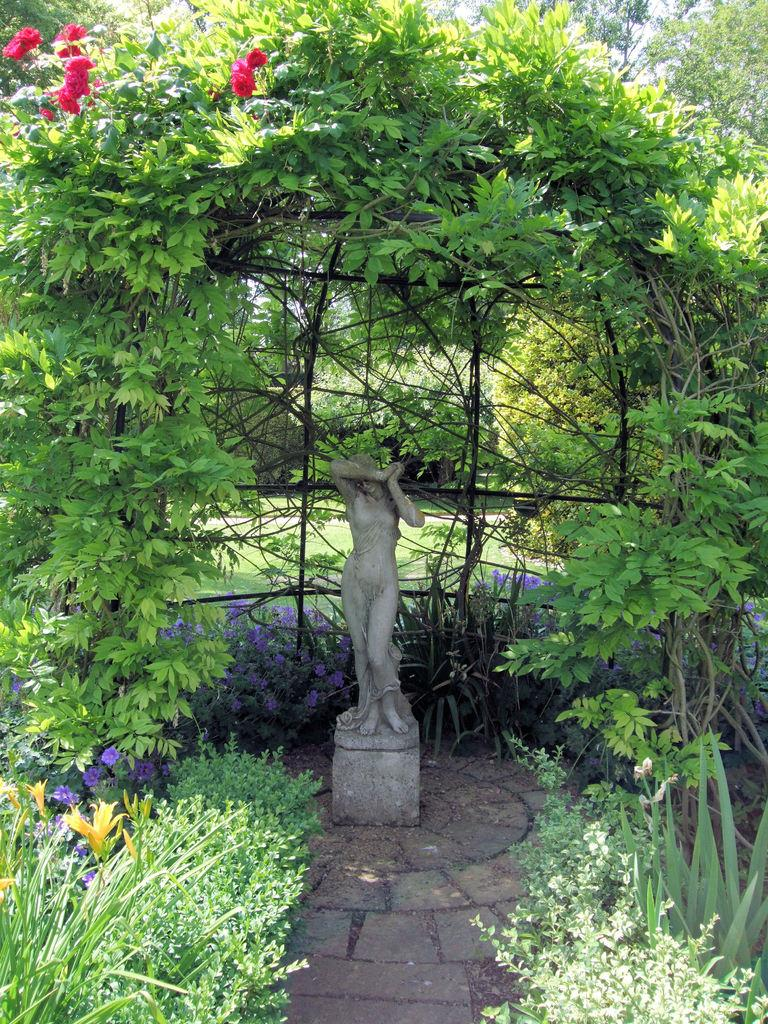What is the main subject of the image? There is a sculpture in the image. What other elements can be seen in the image besides the sculpture? There are plants, trees, and flowers in the image. What type of furniture is depicted in the image? There is no furniture present in the image. What fictional character can be seen interacting with the flowers in the image? There are no fictional characters present in the image. 